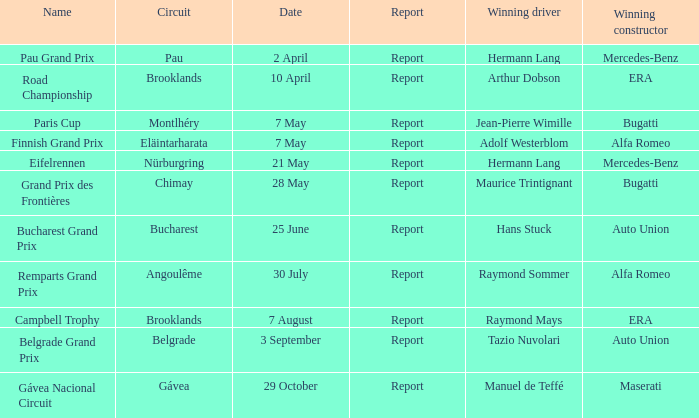Tell me the report for 30 july Report. 